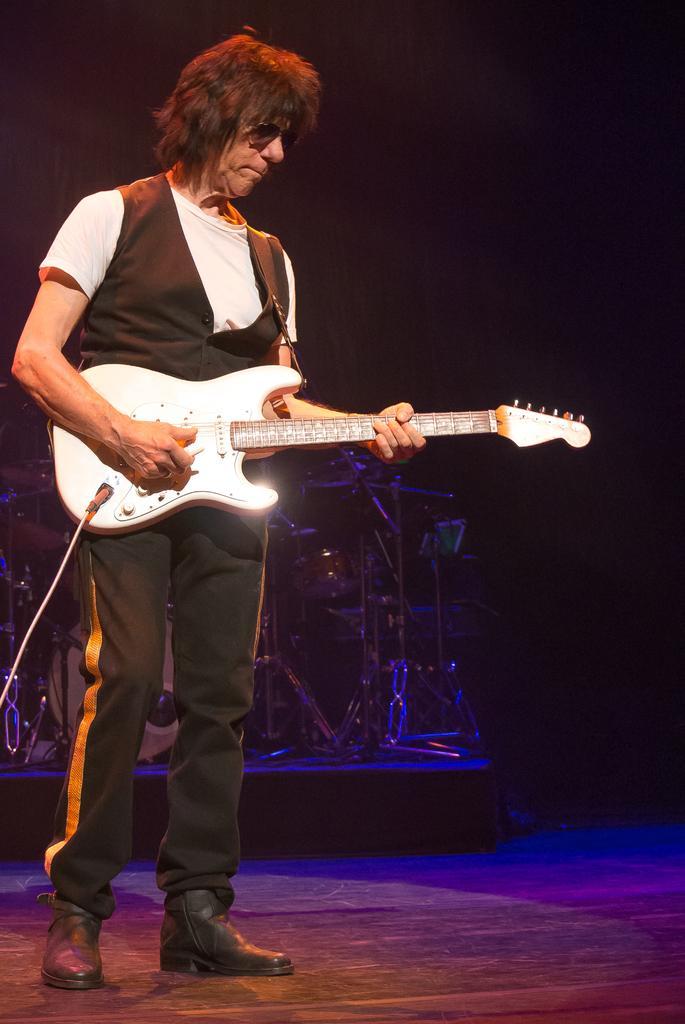Describe this image in one or two sentences. In this image I can see a man standing and playing the guitar on the stage. I can see the drums. 